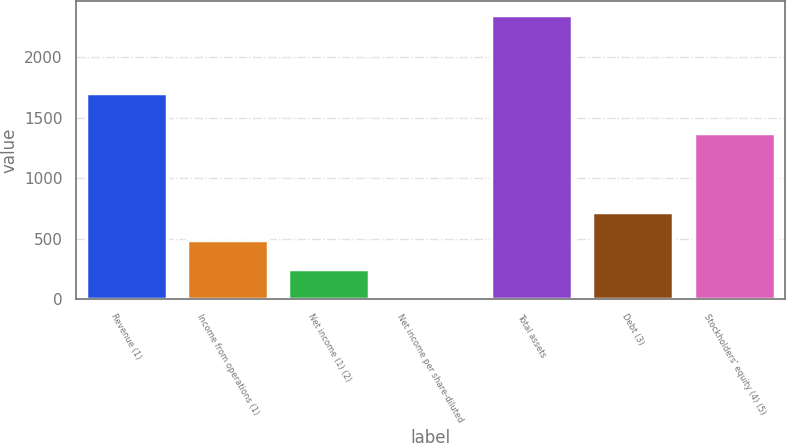Convert chart. <chart><loc_0><loc_0><loc_500><loc_500><bar_chart><fcel>Revenue (1)<fcel>Income from operations (1)<fcel>Net income (1) (2)<fcel>Net income per share-diluted<fcel>Total assets<fcel>Debt (3)<fcel>Stockholders' equity (4) (5)<nl><fcel>1702.1<fcel>486.87<fcel>252.4<fcel>0.81<fcel>2345.5<fcel>721.34<fcel>1376.1<nl></chart> 